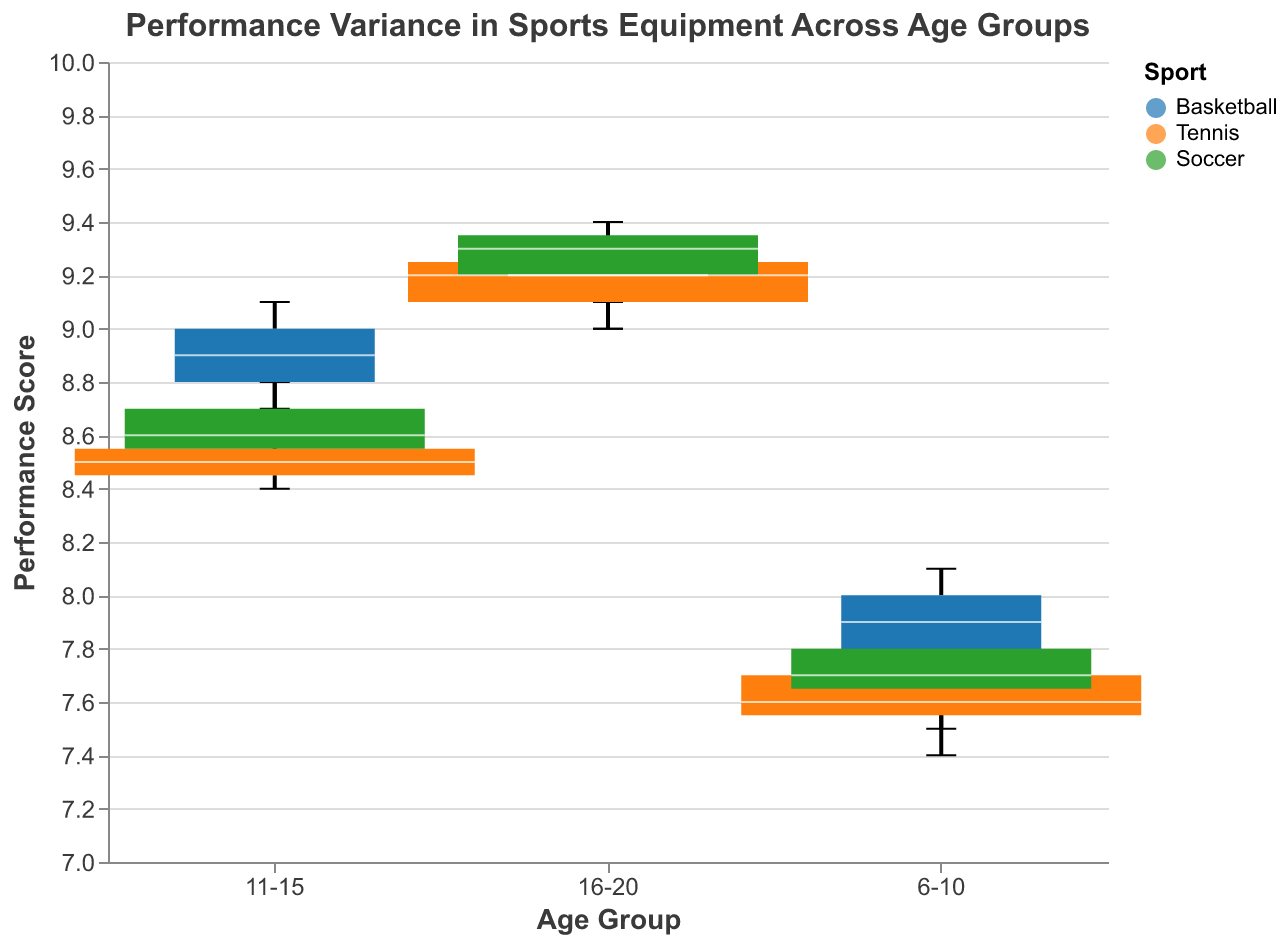What is the title of the figure? The title is usually displayed at the top of the figure. In this case, it is specified in the code as "Performance Variance in Sports Equipment Across Age Groups".
Answer: Performance Variance in Sports Equipment Across Age Groups What is represented on the x-axis? The x-axis represents the grouping of data by age groups. The age groups listed are "6-10", "11-15", and "16-20".
Answer: Age Group What sports are being compared in the figure? The figure differentiates between different sports using colors. In the legend, basketball, tennis, and soccer are the sports listed with their respective color codes.
Answer: Basketball, Tennis, Soccer Which basketball equipment has the highest performance score in the 16-20 age group? By looking at the positions of the box plots in the "16-20" age group for basketball, we can identify the equipment with the highest performance score. The Wilson NCAA Official has the highest median in this group.
Answer: Wilson NCAA Official Which age group shows the highest variance in performance scores for tennis equipment? The variance can be determined by the spread of the boxplots. The greater the spread between the min and max ticks, the higher the variance. For tennis equipment, the widest spread is visible in the "16-20" age group, indicating the highest variance.
Answer: 16-20 Are there any sports where the median performance score increases linearly across age groups? If so, which one? To determine this, examine the median lines for each age group within each sport. Soccer's median performance scores steadily rise from "6-10" to "11-15" to "16-20", indicating a linear increase.
Answer: Soccer How does the median performance score of sports equipment for the 11-15 age group in basketball compare to that in soccer? Locate the medians for basketball and soccer within the 11-15 age group. The basketball median performance score is around 8.9, while for soccer, it is around 8.6.
Answer: Basketball has a higher median performance score What is the difference in the median performance score of tennis equipment between the 6-10 and 16-20 age groups? Identify the median lines for tennis in both age groups. For the "6-10" age group, the median is around 7.6, while for "16-20" it is about 9.0. The difference is calculated as 9.0 - 7.6.
Answer: 1.4 In which age group is the variance in soccer equipment performance lowest? The smallest boxplot width (range from min to max) indicates the lowest variance. For soccer equipment, the "6-10" age group displays the narrowest boxplot, suggesting the lowest variance.
Answer: 6-10 Which age group and sport combination has the highest overall performance score recorded in the data? To find the highest value, locate the max tick across all age groups and sports. The highest tick is at 9.4 in both soccer (16-20 age group with Puma Pro) and basketball (16-20 age group with Wilson NCAA Official).
Answer: 16-20, Basketball and Soccer 